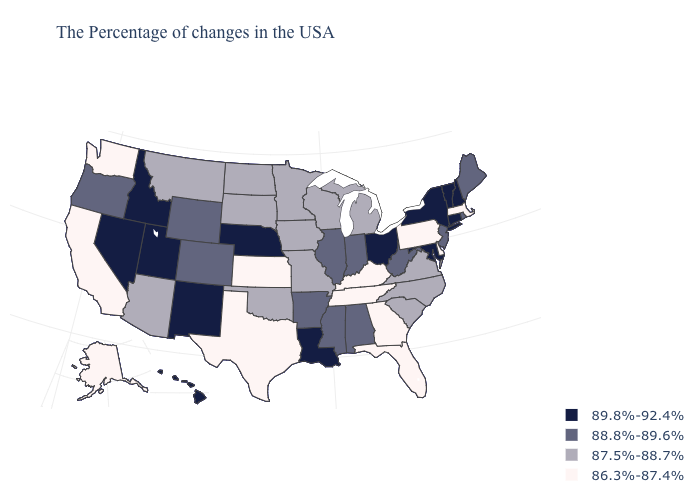Name the states that have a value in the range 88.8%-89.6%?
Keep it brief. Maine, Rhode Island, New Jersey, West Virginia, Indiana, Alabama, Illinois, Mississippi, Arkansas, Wyoming, Colorado, Oregon. What is the value of Hawaii?
Write a very short answer. 89.8%-92.4%. What is the value of Nevada?
Answer briefly. 89.8%-92.4%. Does Montana have a higher value than Wisconsin?
Give a very brief answer. No. Among the states that border Montana , does Idaho have the highest value?
Be succinct. Yes. What is the value of Nevada?
Give a very brief answer. 89.8%-92.4%. Does Hawaii have the highest value in the USA?
Keep it brief. Yes. Which states have the highest value in the USA?
Keep it brief. New Hampshire, Vermont, Connecticut, New York, Maryland, Ohio, Louisiana, Nebraska, New Mexico, Utah, Idaho, Nevada, Hawaii. What is the lowest value in the South?
Answer briefly. 86.3%-87.4%. Does Mississippi have the highest value in the South?
Answer briefly. No. Does the first symbol in the legend represent the smallest category?
Give a very brief answer. No. Does Louisiana have a higher value than Connecticut?
Give a very brief answer. No. What is the highest value in states that border North Carolina?
Concise answer only. 87.5%-88.7%. Does Nevada have the highest value in the USA?
Quick response, please. Yes. Which states have the lowest value in the West?
Write a very short answer. California, Washington, Alaska. 